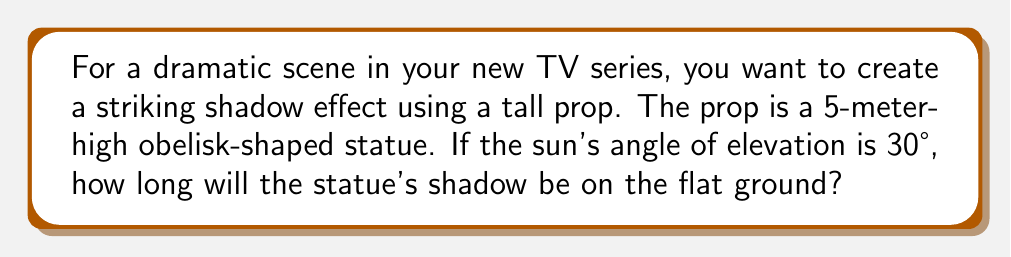What is the answer to this math problem? Let's approach this step-by-step using trigonometry:

1) First, let's visualize the scenario:

[asy]
import geometry;

size(200);
pair A = (0,0), B = (0,5), C = (8.66,0);
draw(A--B--C--A);
draw(B--(8.66,5),dashed);
label("5m",B,W);
label("Shadow",C,S);
label("30°",A,NE);
label("90°",B,SE);
[/asy]

2) We have a right-angled triangle where:
   - The statue's height forms the opposite side (5 meters)
   - The shadow's length is the adjacent side (what we're solving for)
   - The angle of elevation of the sun is 30°

3) In this scenario, we need to use the tangent function. Recall that:

   $\tan(\theta) = \frac{\text{opposite}}{\text{adjacent}}$

4) Substituting our known values:

   $\tan(30°) = \frac{5}{\text{shadow length}}$

5) We know that $\tan(30°) = \frac{1}{\sqrt{3}}$, so:

   $\frac{1}{\sqrt{3}} = \frac{5}{\text{shadow length}}$

6) Cross multiply:

   $\text{shadow length} = 5 \sqrt{3}$

7) Calculate the final value:

   $\text{shadow length} = 5 \times 1.732 \approx 8.66$ meters
Answer: $8.66$ meters 